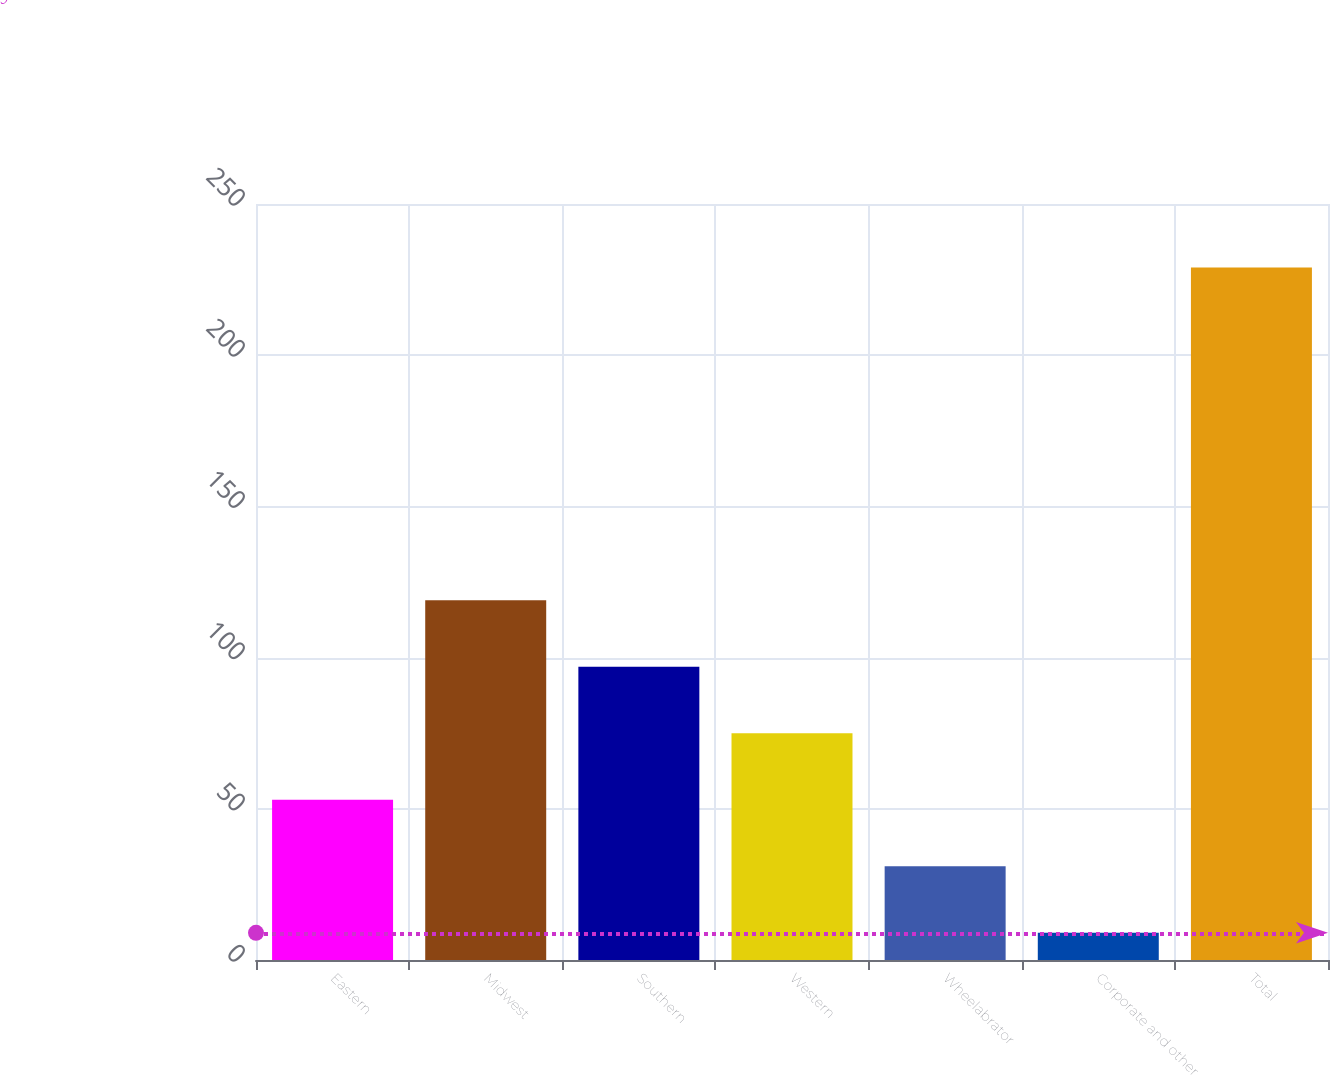Convert chart. <chart><loc_0><loc_0><loc_500><loc_500><bar_chart><fcel>Eastern<fcel>Midwest<fcel>Southern<fcel>Western<fcel>Wheelabrator<fcel>Corporate and other<fcel>Total<nl><fcel>53<fcel>119<fcel>97<fcel>75<fcel>31<fcel>9<fcel>229<nl></chart> 